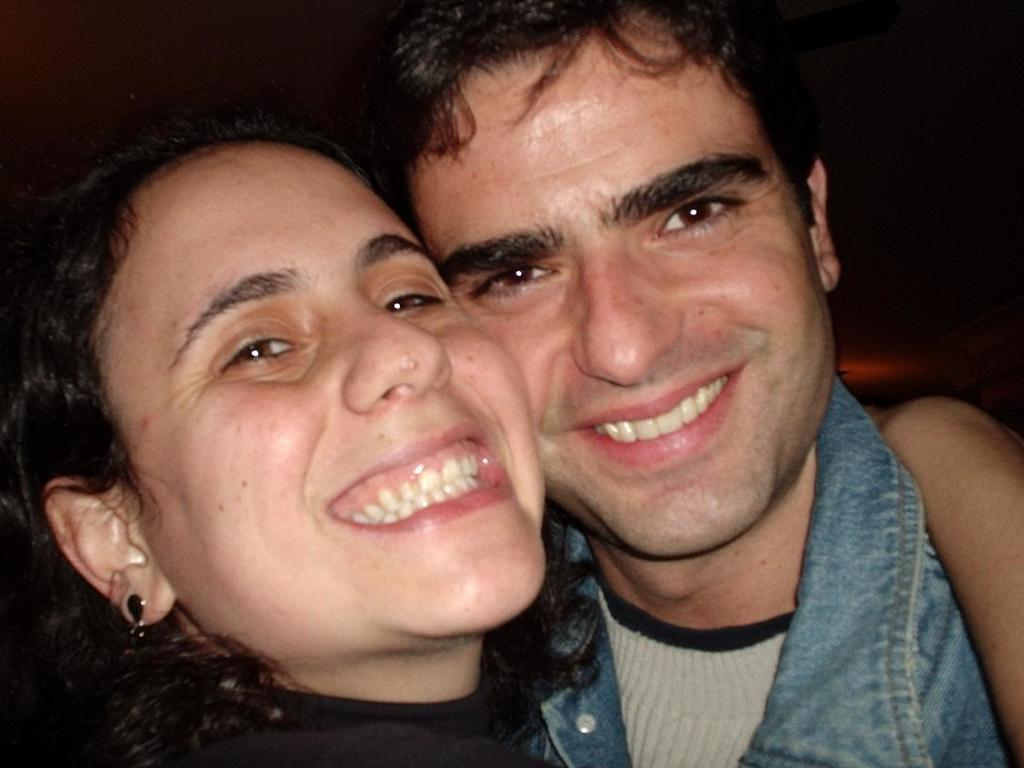How many people are in the image? There are two persons in the image. What is the woman wearing? The woman is wearing a black dress. What is the man wearing? The man is wearing a jeans shirt. What is the color of the background in the image? The background of the image is dark. What type of crime is being committed in the image? There is no indication of a crime being committed in the image. Can you see any cows in the image? There are no cows present in the image. 